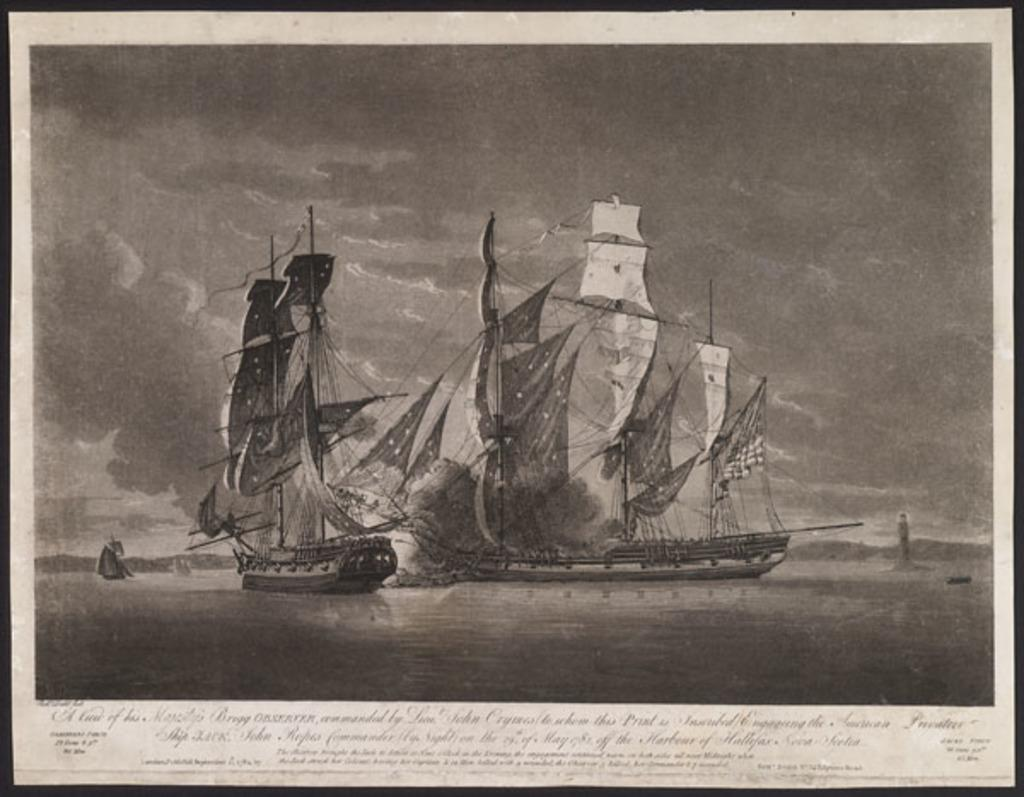What is the color scheme of the image? The image is black and white. What can be seen on the water in the image? There are ships on the water in the image. What type of vegetation is visible in the background of the image? There is a tree visible in the background of the image. What is present at the bottom of the image? There is text at the bottom of the image. What type of trail can be seen leading up to the ships in the image? There is no trail visible in the image; it only features ships on the water, a tree in the background, and text at the bottom. 